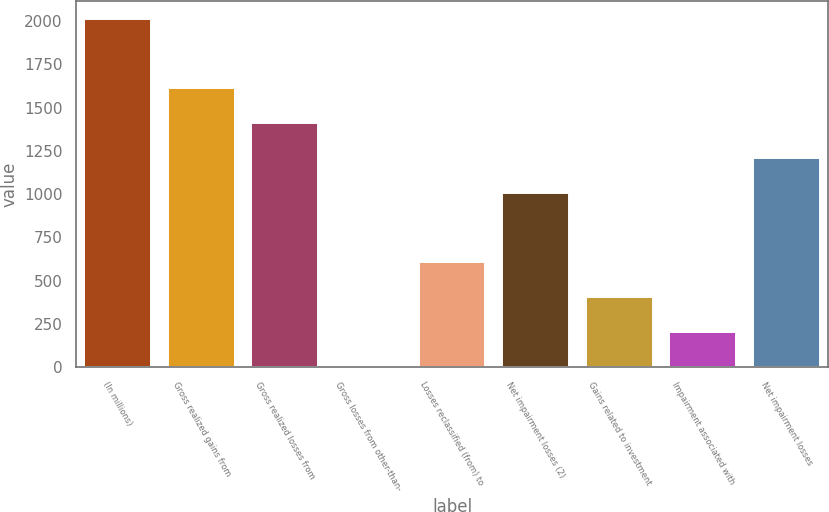<chart> <loc_0><loc_0><loc_500><loc_500><bar_chart><fcel>(In millions)<fcel>Gross realized gains from<fcel>Gross realized losses from<fcel>Gross losses from other-than-<fcel>Losses reclassified (from) to<fcel>Net impairment losses (2)<fcel>Gains related to investment<fcel>Impairment associated with<fcel>Net impairment losses<nl><fcel>2014<fcel>1611.4<fcel>1410.1<fcel>1<fcel>604.9<fcel>1007.5<fcel>403.6<fcel>202.3<fcel>1208.8<nl></chart> 